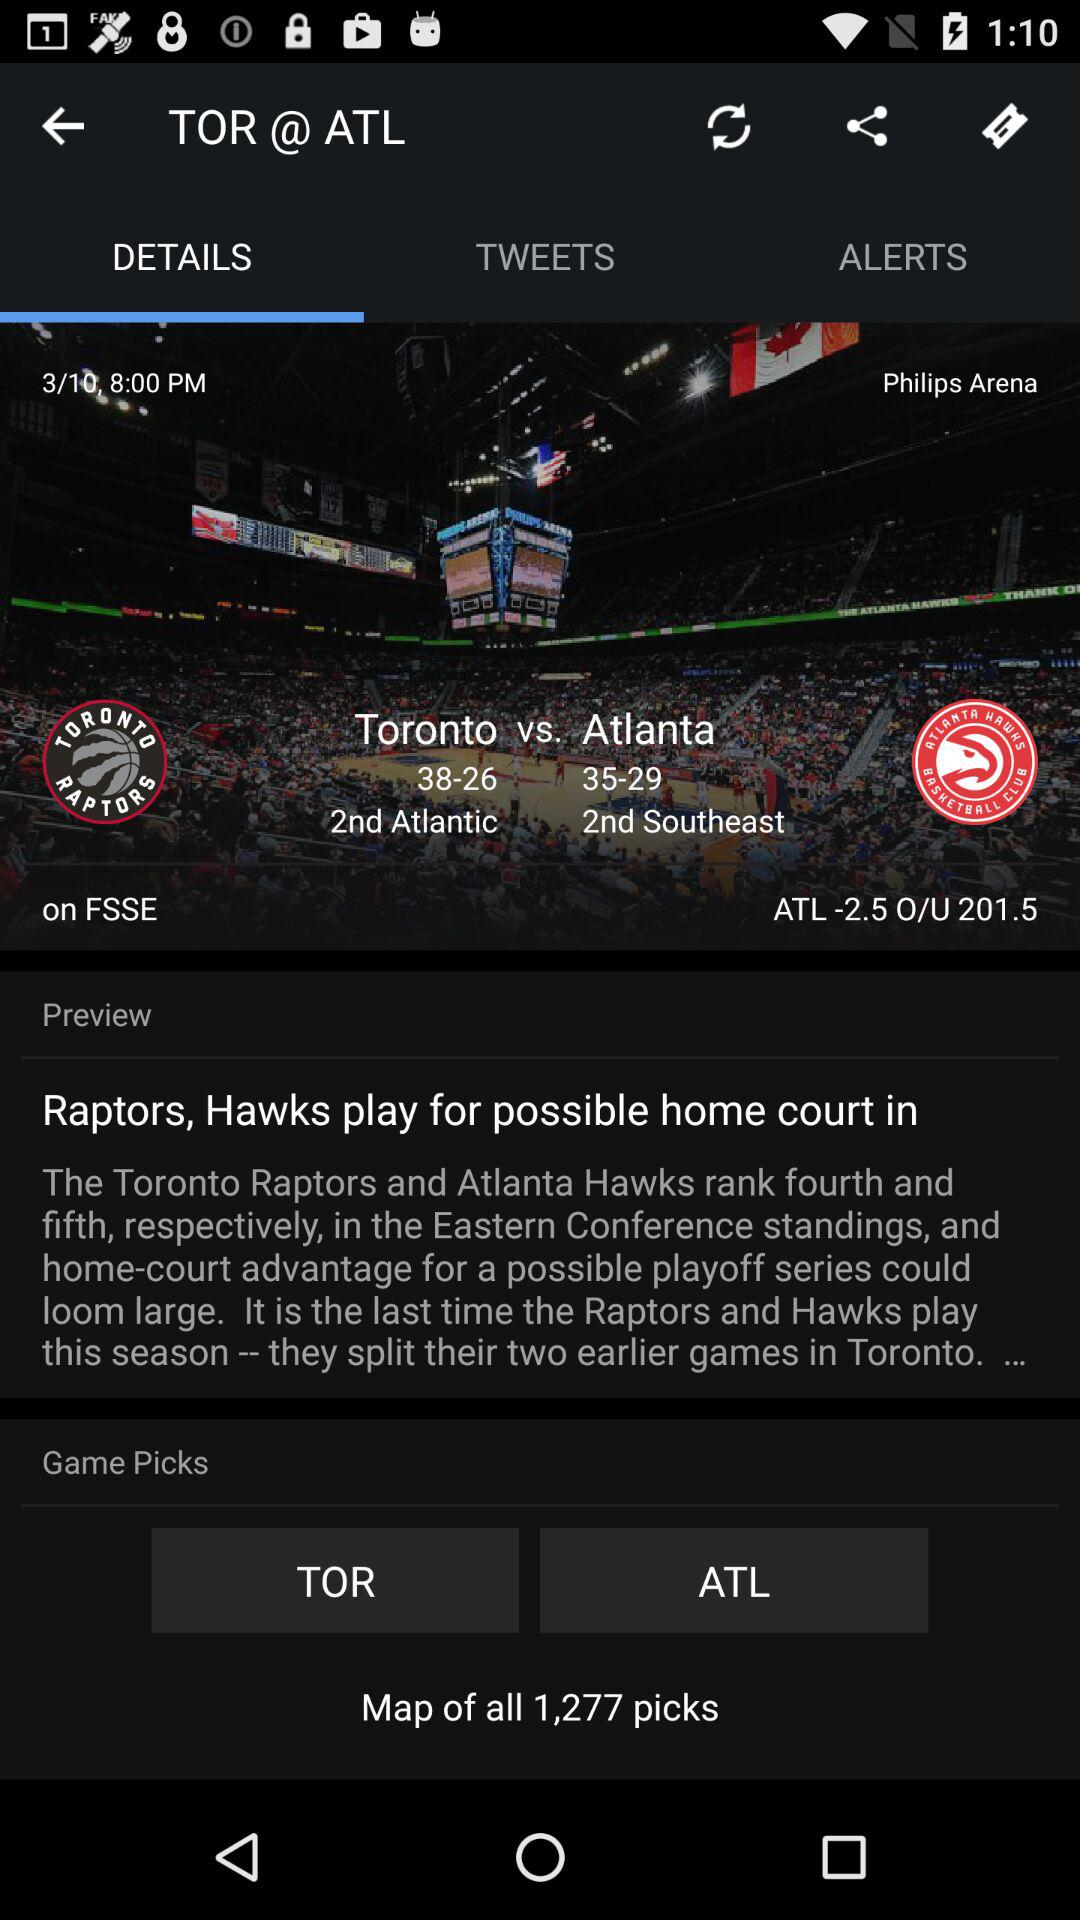How many total pages are there? There are 10 pages in total. 